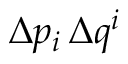Convert formula to latex. <formula><loc_0><loc_0><loc_500><loc_500>\Delta p _ { i } \, \Delta q ^ { i }</formula> 